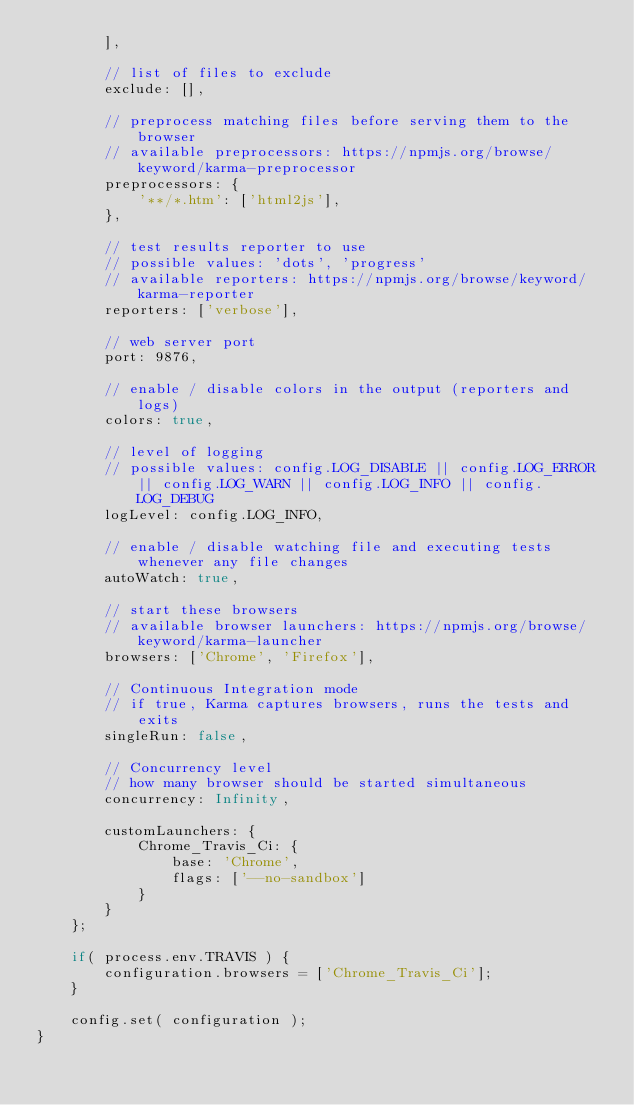<code> <loc_0><loc_0><loc_500><loc_500><_JavaScript_>        ],

        // list of files to exclude
        exclude: [],

        // preprocess matching files before serving them to the browser
        // available preprocessors: https://npmjs.org/browse/keyword/karma-preprocessor
        preprocessors: {
            '**/*.htm': ['html2js'],
        },

        // test results reporter to use
        // possible values: 'dots', 'progress'
        // available reporters: https://npmjs.org/browse/keyword/karma-reporter
        reporters: ['verbose'],

        // web server port
        port: 9876,

        // enable / disable colors in the output (reporters and logs)
        colors: true,

        // level of logging
        // possible values: config.LOG_DISABLE || config.LOG_ERROR || config.LOG_WARN || config.LOG_INFO || config.LOG_DEBUG
        logLevel: config.LOG_INFO,

        // enable / disable watching file and executing tests whenever any file changes
        autoWatch: true,

        // start these browsers
        // available browser launchers: https://npmjs.org/browse/keyword/karma-launcher
        browsers: ['Chrome', 'Firefox'],

        // Continuous Integration mode
        // if true, Karma captures browsers, runs the tests and exits
        singleRun: false,

        // Concurrency level
        // how many browser should be started simultaneous
        concurrency: Infinity,

        customLaunchers: {
            Chrome_Travis_Ci: {
                base: 'Chrome',
                flags: ['--no-sandbox']
            }
        }
    };

    if( process.env.TRAVIS ) {
        configuration.browsers = ['Chrome_Travis_Ci'];
    }

    config.set( configuration );
}
</code> 